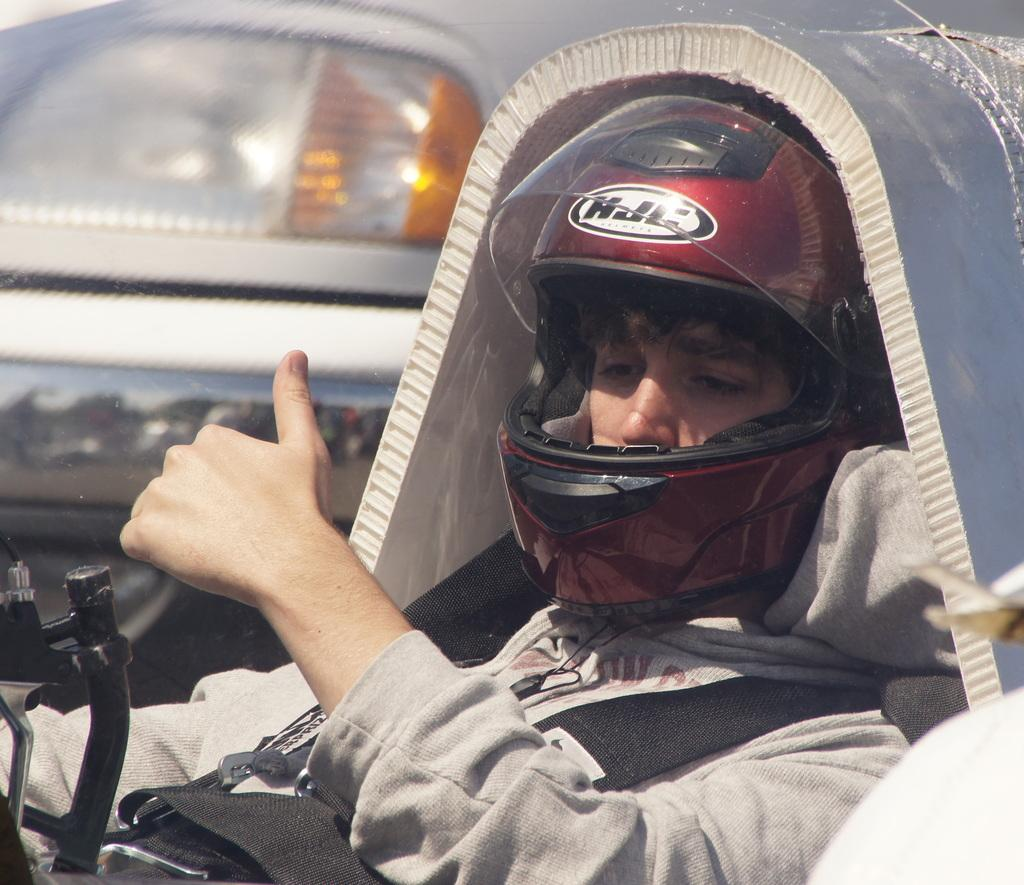Who or what is present in the image? There is a person in the image. What is the person wearing on their head? There is a helmet in the image. What can be seen in the background of the image? There is a vehicle and other objects in the background of the image. Can you describe the object on the right side of the image? There is an object on the right side of the image, but its specific details are not mentioned in the facts. What type of honey is being collected from the hydrant in the image? There is no honey or hydrant present in the image. How many baskets are visible in the image? There is no mention of baskets in the image, so it is not possible to determine their presence or quantity. 